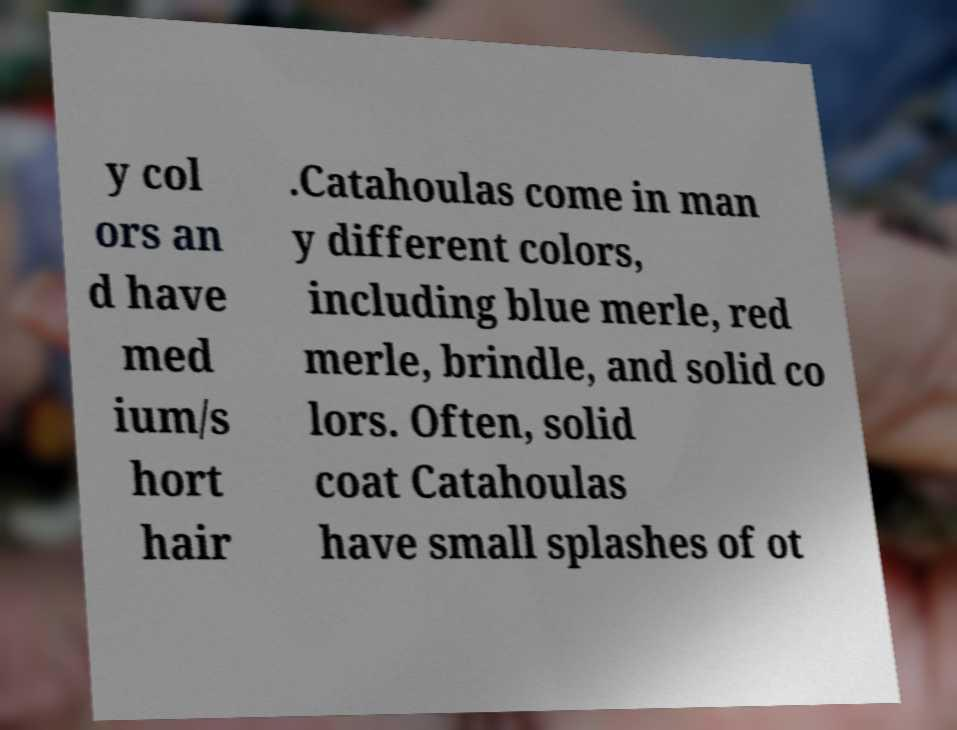For documentation purposes, I need the text within this image transcribed. Could you provide that? y col ors an d have med ium/s hort hair .Catahoulas come in man y different colors, including blue merle, red merle, brindle, and solid co lors. Often, solid coat Catahoulas have small splashes of ot 